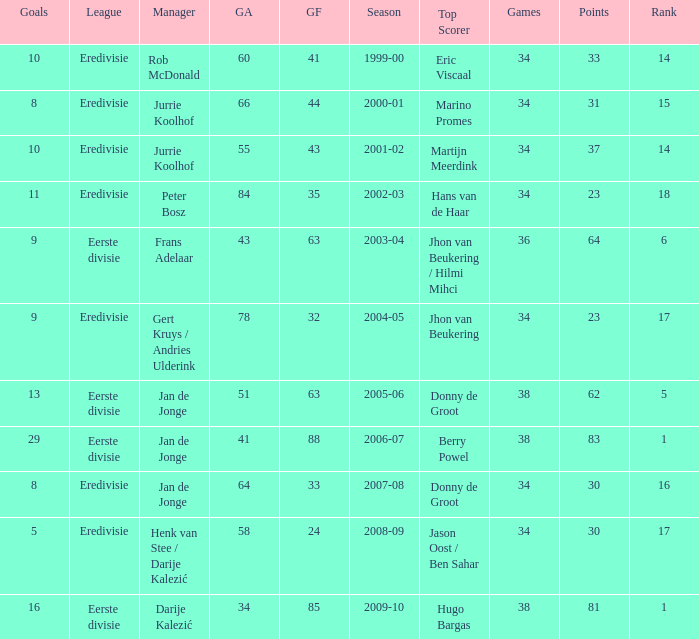Who is the top scorer where gf is 41? Eric Viscaal. 